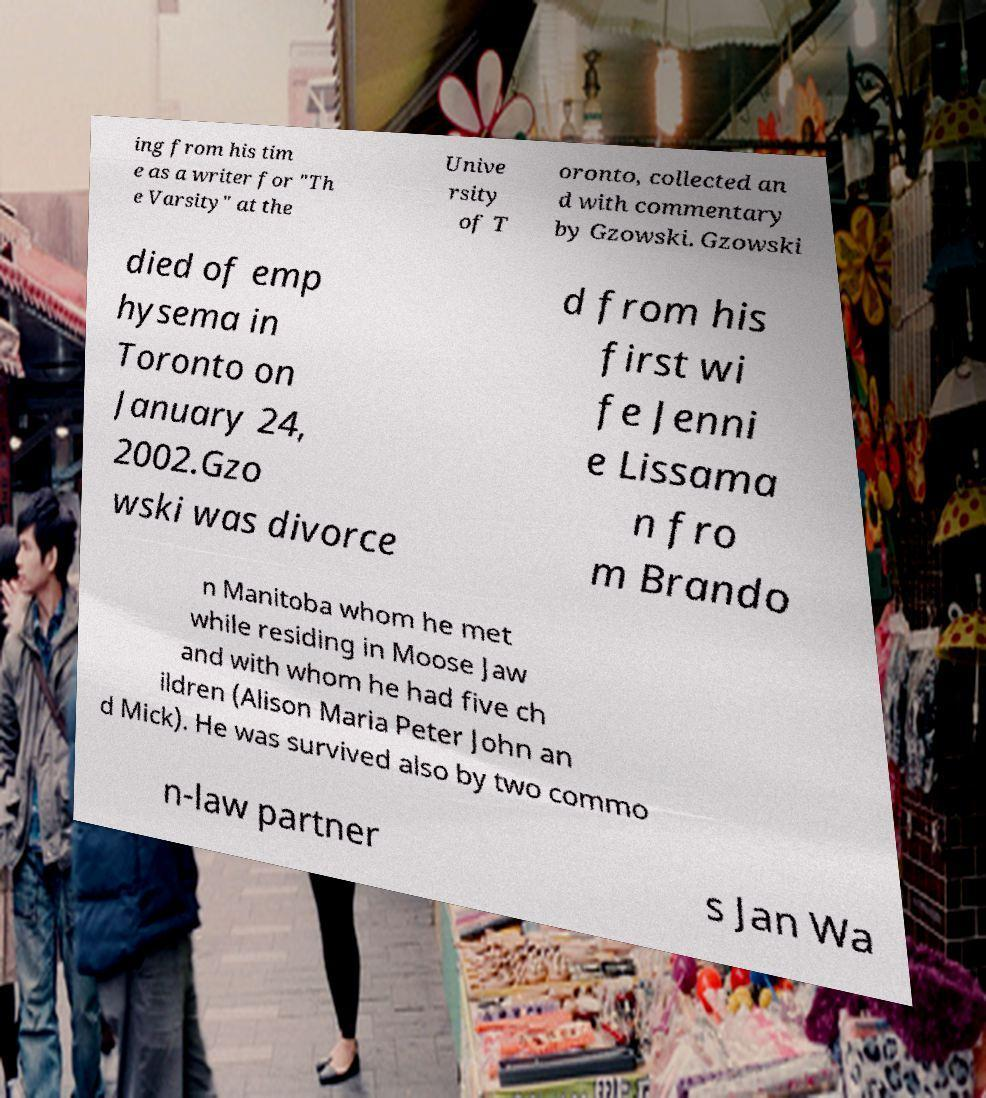Could you assist in decoding the text presented in this image and type it out clearly? ing from his tim e as a writer for "Th e Varsity" at the Unive rsity of T oronto, collected an d with commentary by Gzowski. Gzowski died of emp hysema in Toronto on January 24, 2002.Gzo wski was divorce d from his first wi fe Jenni e Lissama n fro m Brando n Manitoba whom he met while residing in Moose Jaw and with whom he had five ch ildren (Alison Maria Peter John an d Mick). He was survived also by two commo n-law partner s Jan Wa 